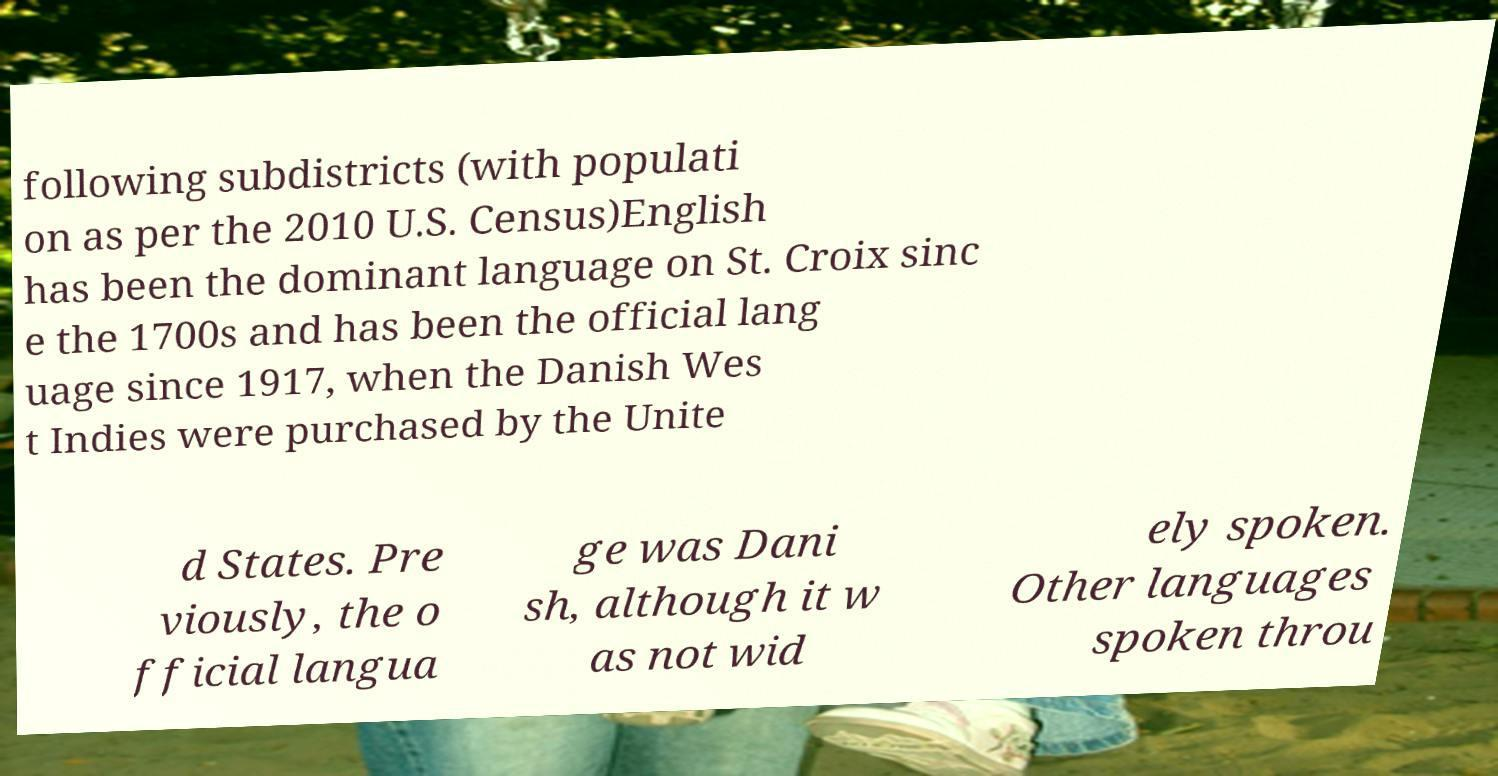Please identify and transcribe the text found in this image. following subdistricts (with populati on as per the 2010 U.S. Census)English has been the dominant language on St. Croix sinc e the 1700s and has been the official lang uage since 1917, when the Danish Wes t Indies were purchased by the Unite d States. Pre viously, the o fficial langua ge was Dani sh, although it w as not wid ely spoken. Other languages spoken throu 